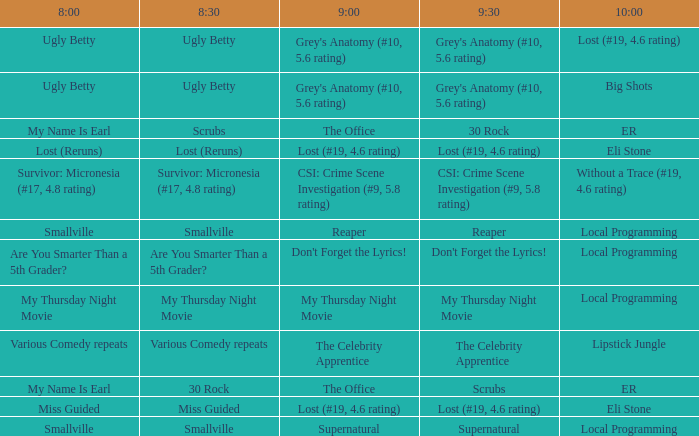What is at 9:00 when at 10:00 it is local programming and at 9:30 it is my thursday night movie? My Thursday Night Movie. 